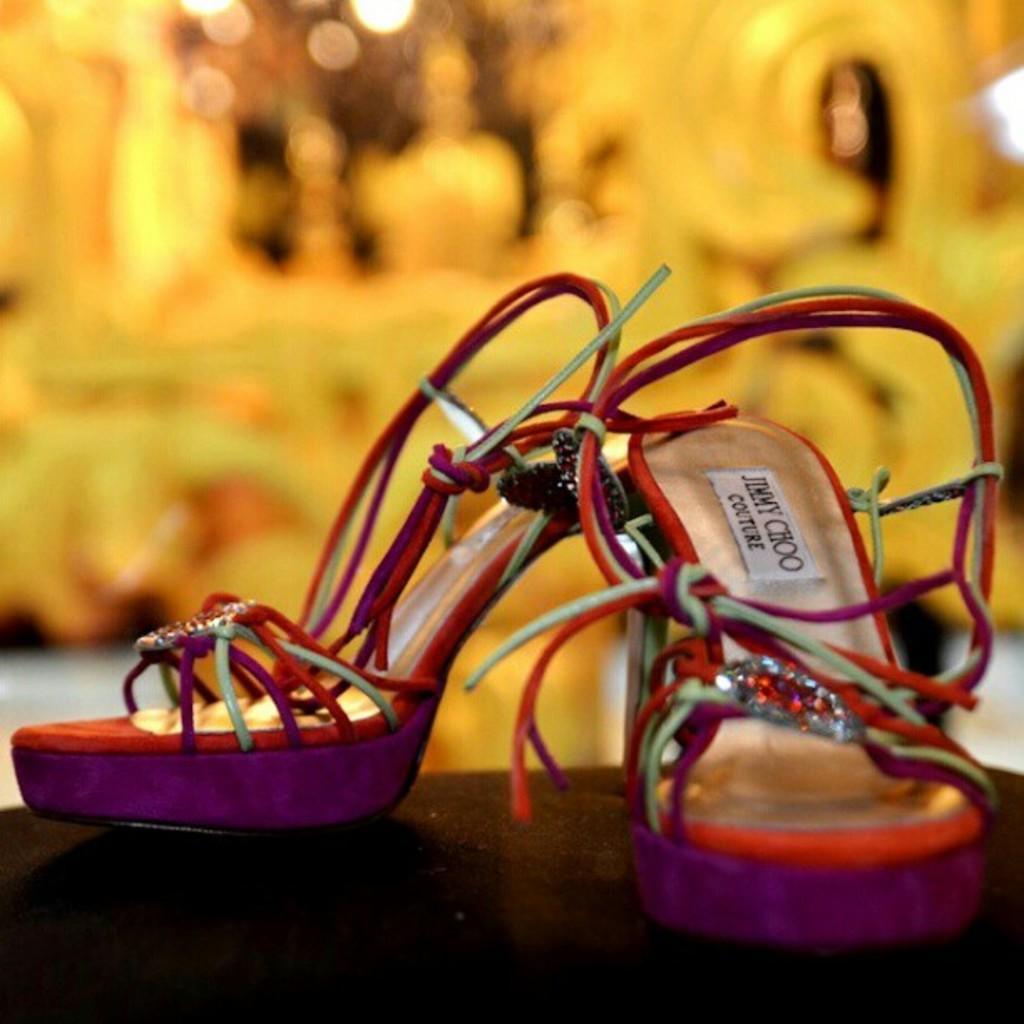Can you describe this image briefly? In this picture we can see heels and blurry background. 